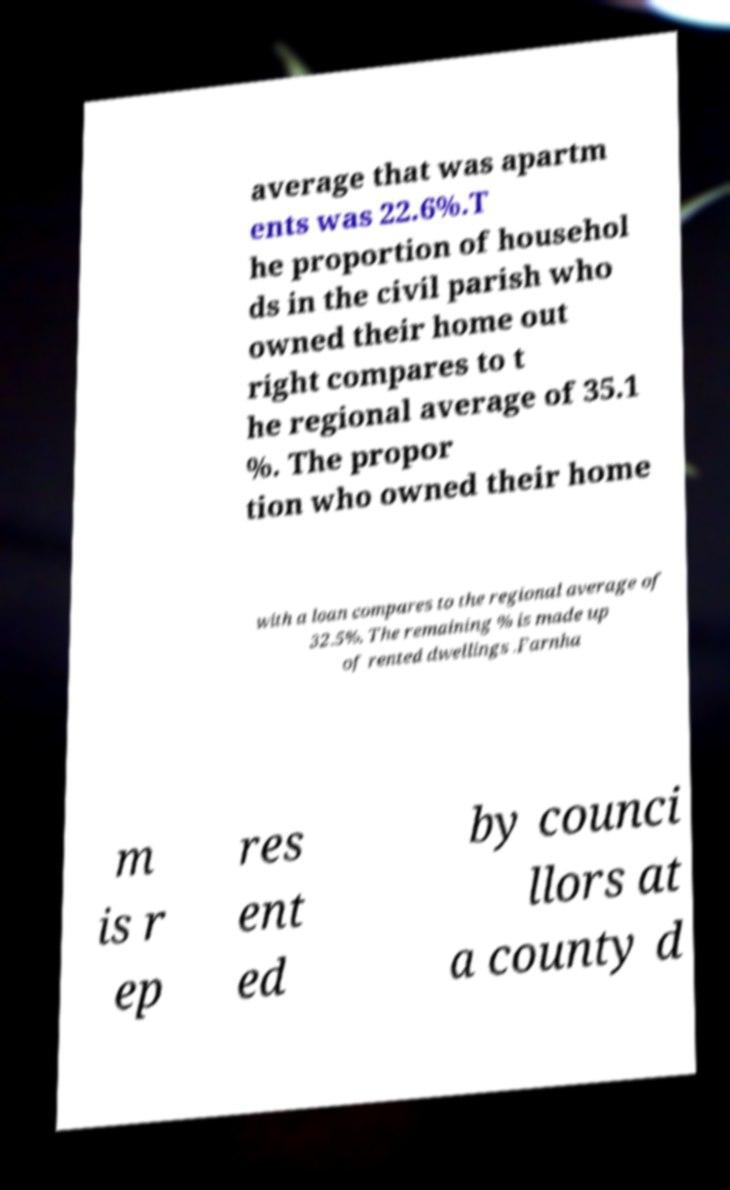For documentation purposes, I need the text within this image transcribed. Could you provide that? average that was apartm ents was 22.6%.T he proportion of househol ds in the civil parish who owned their home out right compares to t he regional average of 35.1 %. The propor tion who owned their home with a loan compares to the regional average of 32.5%. The remaining % is made up of rented dwellings .Farnha m is r ep res ent ed by counci llors at a county d 